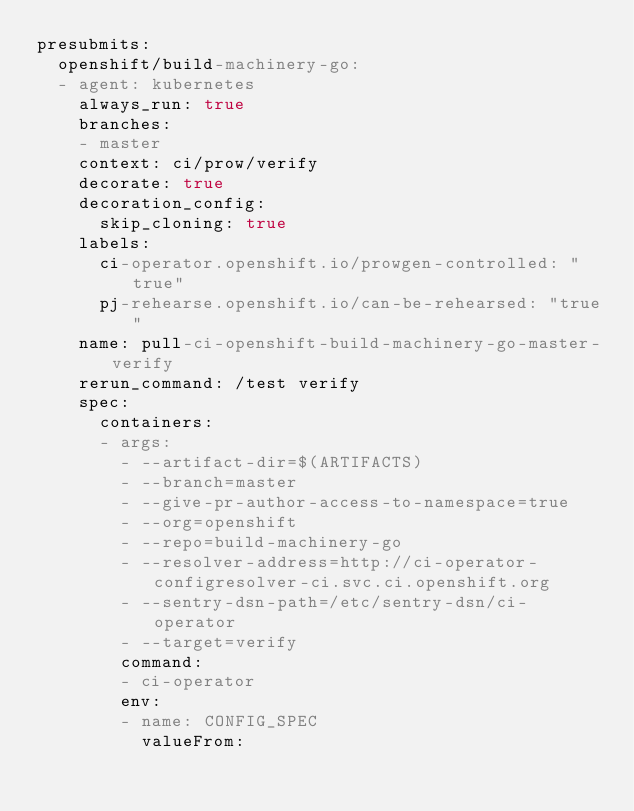<code> <loc_0><loc_0><loc_500><loc_500><_YAML_>presubmits:
  openshift/build-machinery-go:
  - agent: kubernetes
    always_run: true
    branches:
    - master
    context: ci/prow/verify
    decorate: true
    decoration_config:
      skip_cloning: true
    labels:
      ci-operator.openshift.io/prowgen-controlled: "true"
      pj-rehearse.openshift.io/can-be-rehearsed: "true"
    name: pull-ci-openshift-build-machinery-go-master-verify
    rerun_command: /test verify
    spec:
      containers:
      - args:
        - --artifact-dir=$(ARTIFACTS)
        - --branch=master
        - --give-pr-author-access-to-namespace=true
        - --org=openshift
        - --repo=build-machinery-go
        - --resolver-address=http://ci-operator-configresolver-ci.svc.ci.openshift.org
        - --sentry-dsn-path=/etc/sentry-dsn/ci-operator
        - --target=verify
        command:
        - ci-operator
        env:
        - name: CONFIG_SPEC
          valueFrom:</code> 